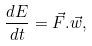<formula> <loc_0><loc_0><loc_500><loc_500>\frac { d E } { d t } = \vec { F } . \vec { w } ,</formula> 